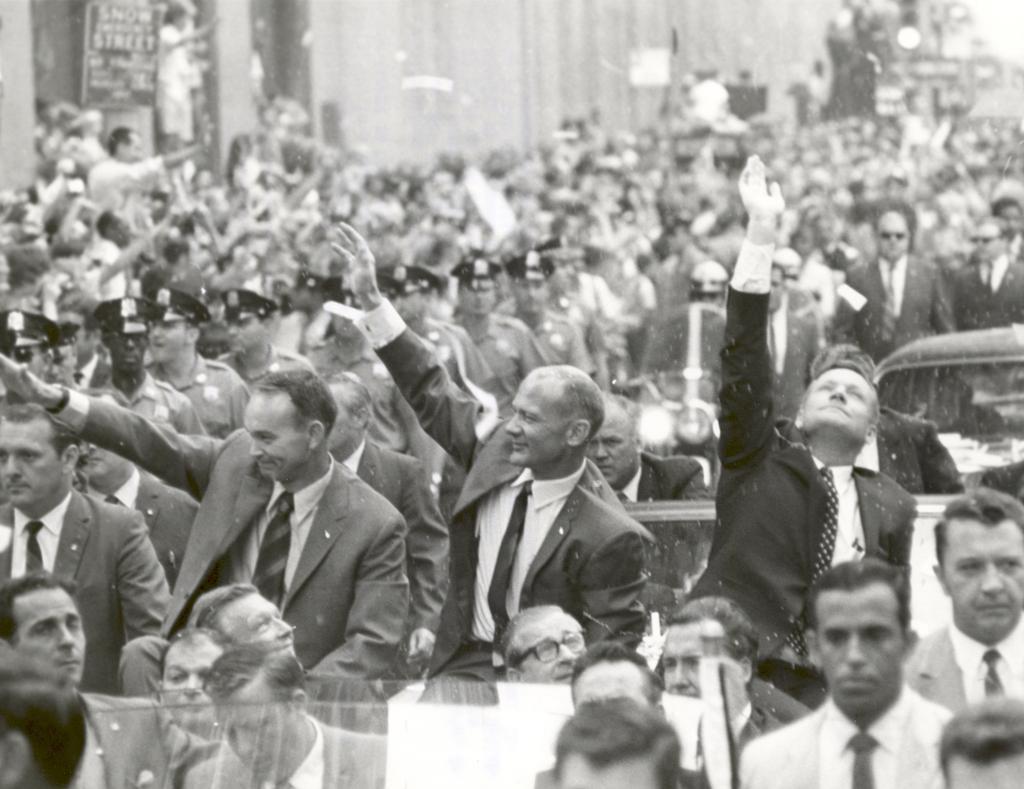Describe this image in one or two sentences. In this picture there are group of people standing on the road and there are group of people standing on the vehicle. At the back there is a building and there is a board on the wall. 